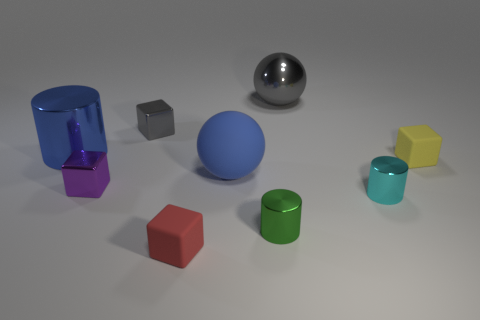What shape is the purple metallic thing that is the same size as the cyan cylinder? The purple metallic object of interest is a cube, which shares the same size as the cyan cylinder in the image. 